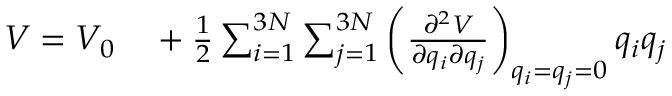<formula> <loc_0><loc_0><loc_500><loc_500>\begin{array} { r l } { V = V _ { 0 } } & + \frac { 1 } { 2 } \sum _ { i = 1 } ^ { 3 N } \sum _ { j = 1 } ^ { 3 N } \left ( \frac { \partial ^ { 2 } V } { \partial q _ { i } \partial q _ { j } } \right ) _ { q _ { i } = q _ { j } = 0 } q _ { i } q _ { j } } \end{array}</formula> 